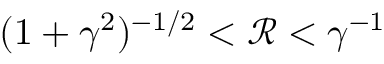Convert formula to latex. <formula><loc_0><loc_0><loc_500><loc_500>( 1 + \gamma ^ { 2 } ) ^ { - 1 / 2 } < \mathcal { R } < \gamma ^ { - 1 }</formula> 